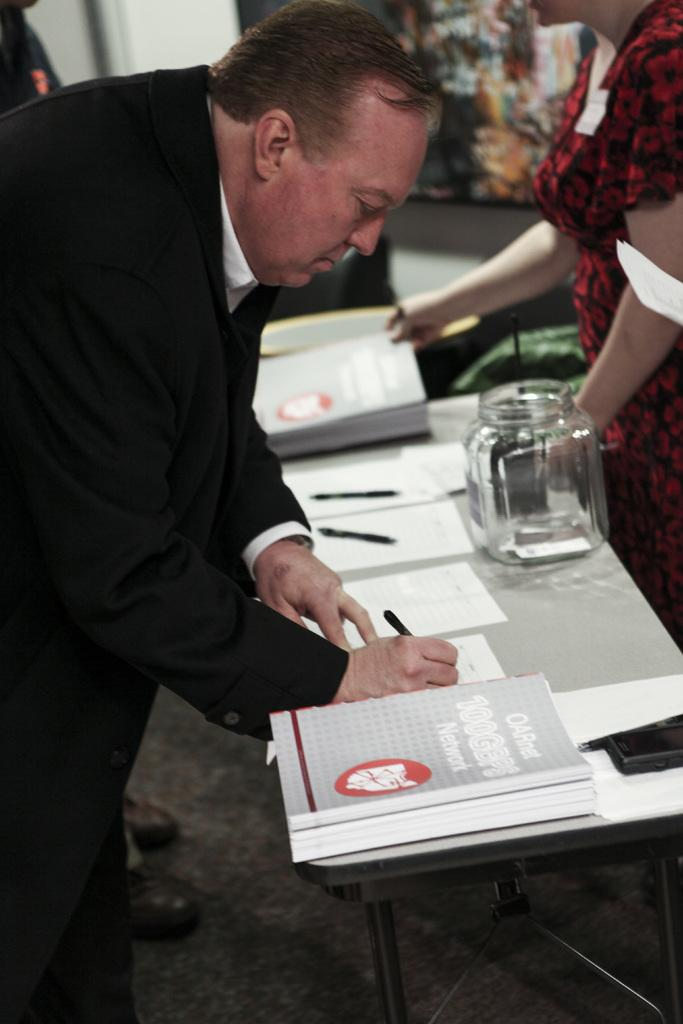How many people are in the image? There are two persons standing in the image. What is one person holding? One person is holding a pen. What objects can be seen on the table in the image? On the table, there is a jar, a book, a paper, and a pen. What is visible on the wall in the background? There is a frame on the wall in the background. What part of the room can be seen in the image? The floor is visible in the image. Is there a volcano erupting in the background of the image? No, there is no volcano present in the image. How many screws can be seen on the table in the image? There are no screws visible in the image. 